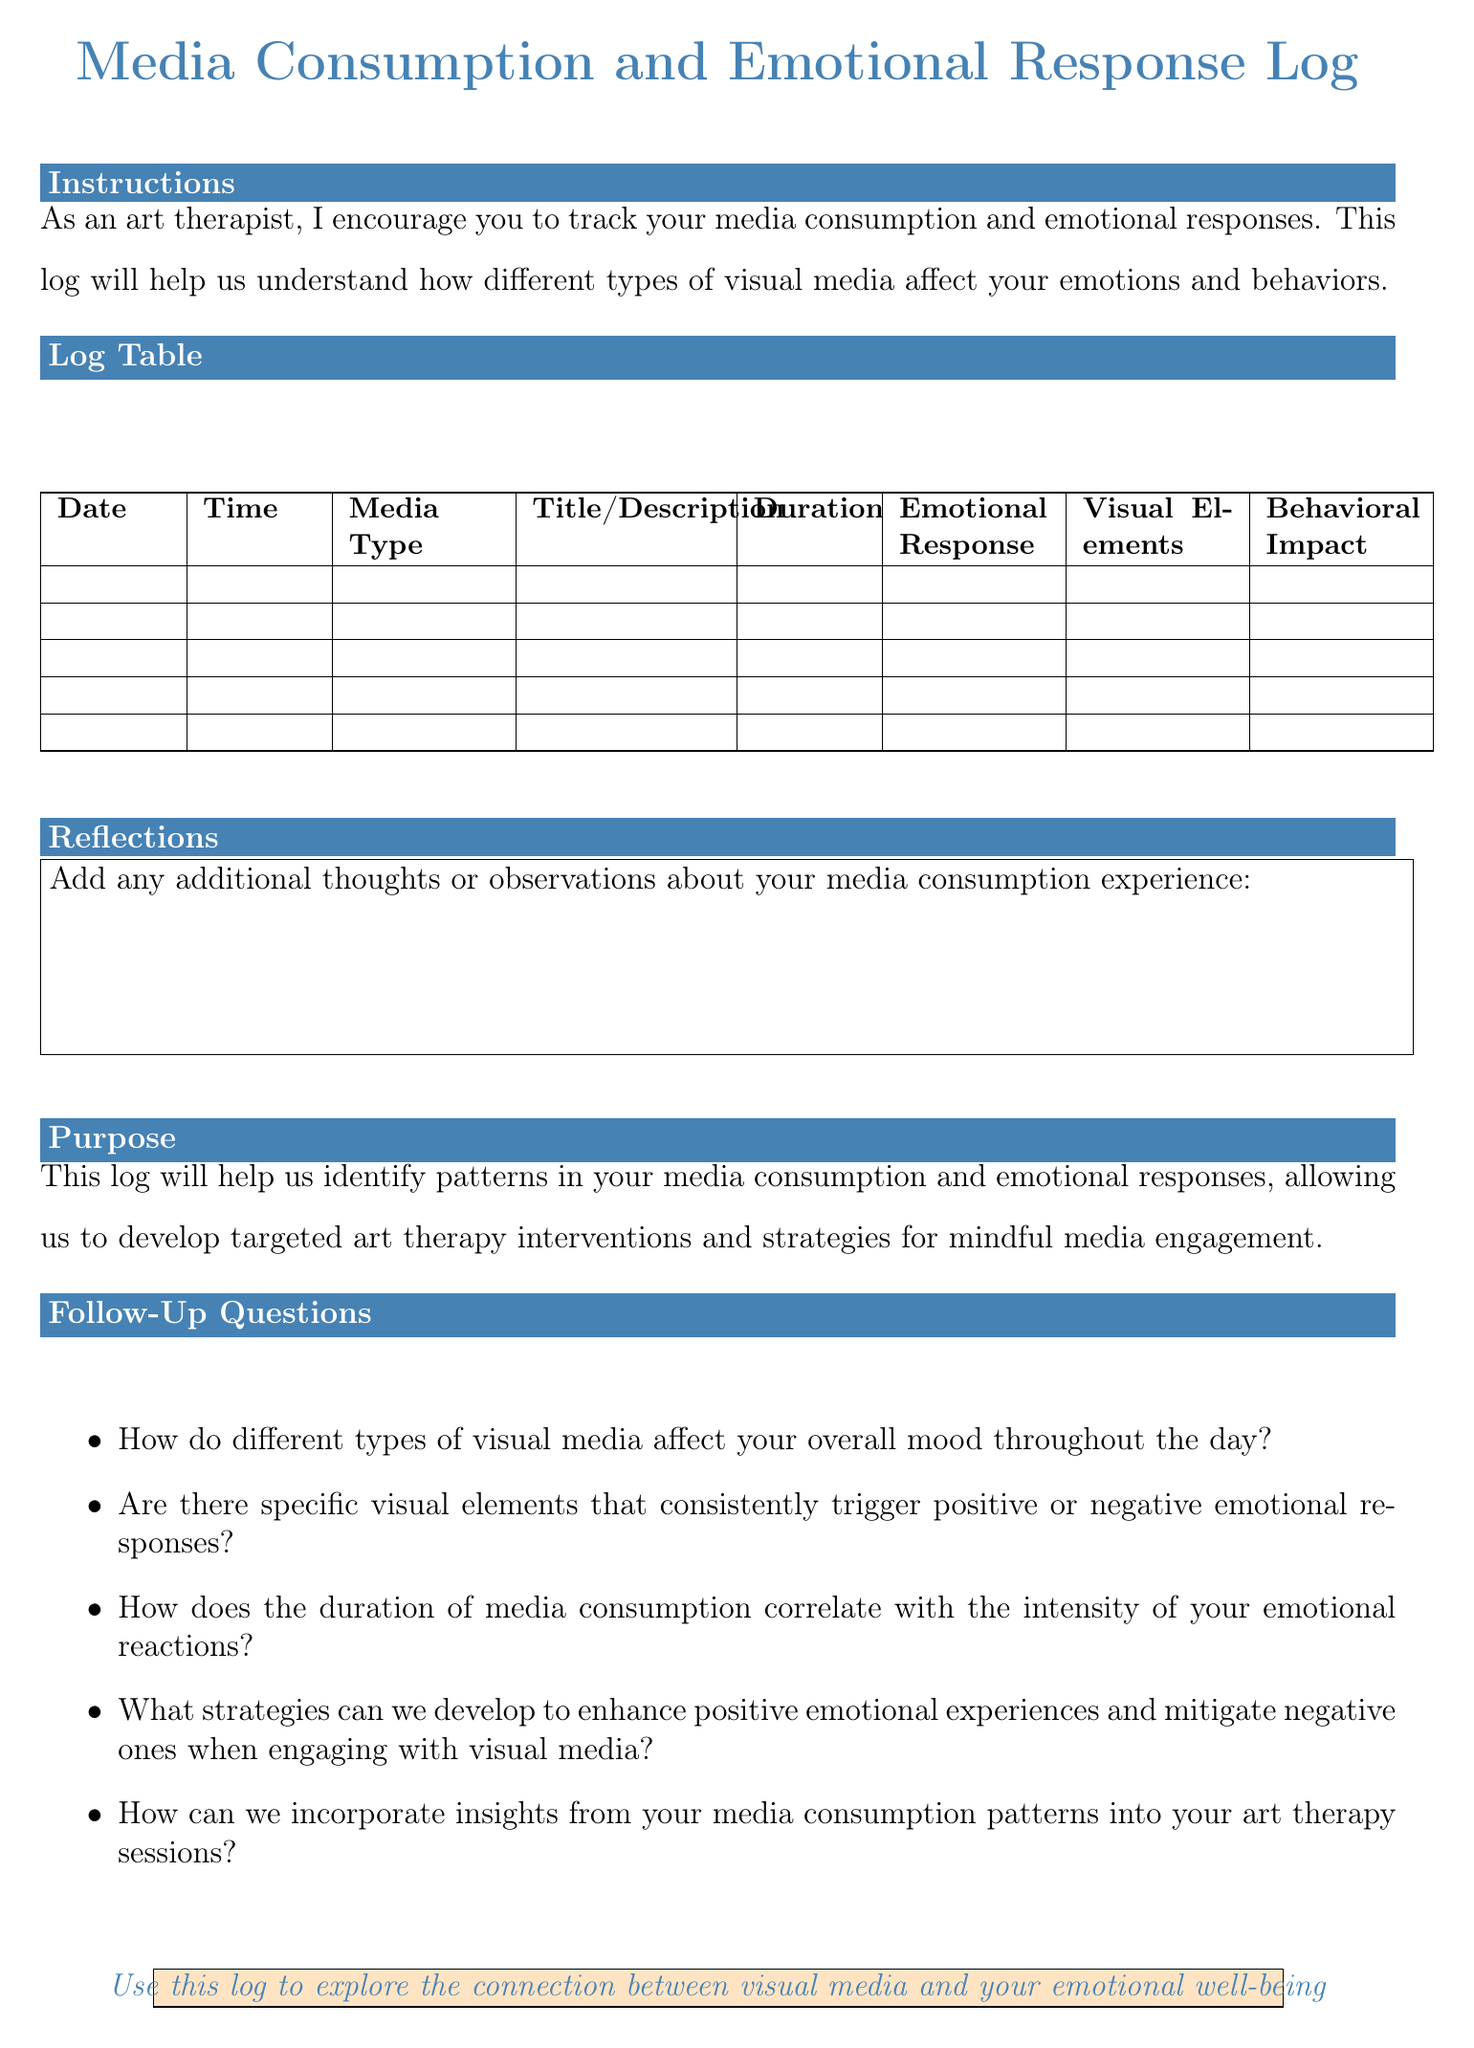What is the title of the log? The title of the log is the prominent header of the document that describes its purpose.
Answer: Media Consumption and Emotional Response Log What is the purpose of this log? The purpose statement summarizes the overall aim of the log.
Answer: To identify patterns in media consumption and emotional responses How many columns are included in the log table? The document specifies the number of distinct columns present in the log table.
Answer: 8 What type of media is listed as an example under "Media Type"? This is a sample entry under the "Media Type" column demonstrating what to document.
Answer: Netflix series Give an example of an emotional response format provided in the log. The log provides specific examples for how to describe emotional reactions.
Answer: Anxiety (7/10) What should be noted in the "Duration" column? The document describes what kind of information needs to be recorded in this specific column.
Answer: How long you engaged with the media What color is specified for the header in the document? This refers to the color used in the header for aesthetic purposes.
Answer: maincolor What is one reflection item encouraged in the log? The document indicates what kind of insights or thoughts can be added at the end of the log.
Answer: Additional thoughts or observations about your media consumption experience 